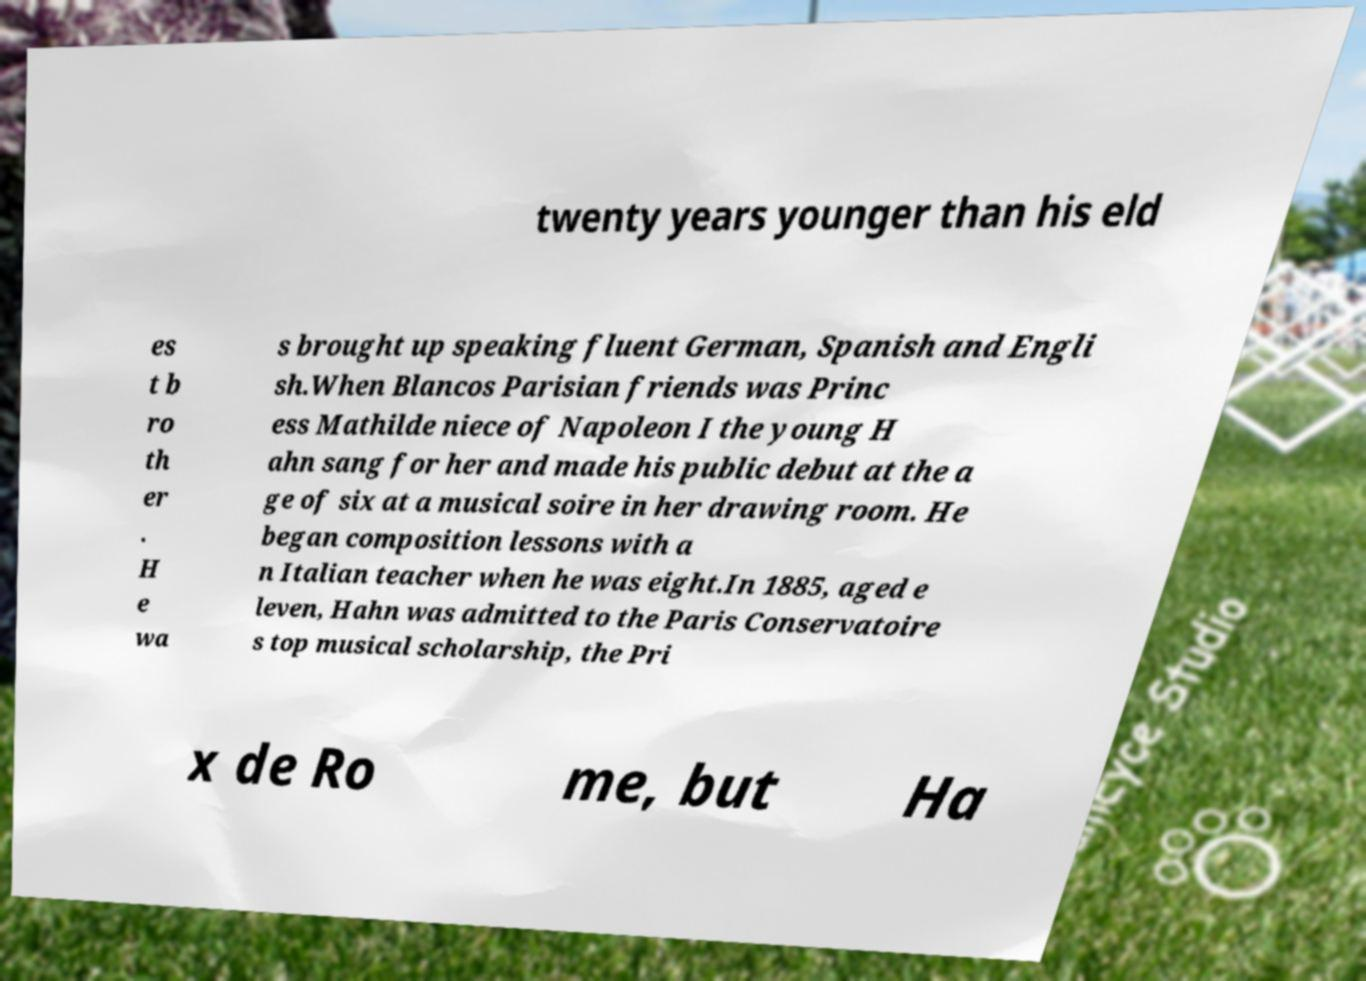Can you read and provide the text displayed in the image?This photo seems to have some interesting text. Can you extract and type it out for me? twenty years younger than his eld es t b ro th er . H e wa s brought up speaking fluent German, Spanish and Engli sh.When Blancos Parisian friends was Princ ess Mathilde niece of Napoleon I the young H ahn sang for her and made his public debut at the a ge of six at a musical soire in her drawing room. He began composition lessons with a n Italian teacher when he was eight.In 1885, aged e leven, Hahn was admitted to the Paris Conservatoire s top musical scholarship, the Pri x de Ro me, but Ha 